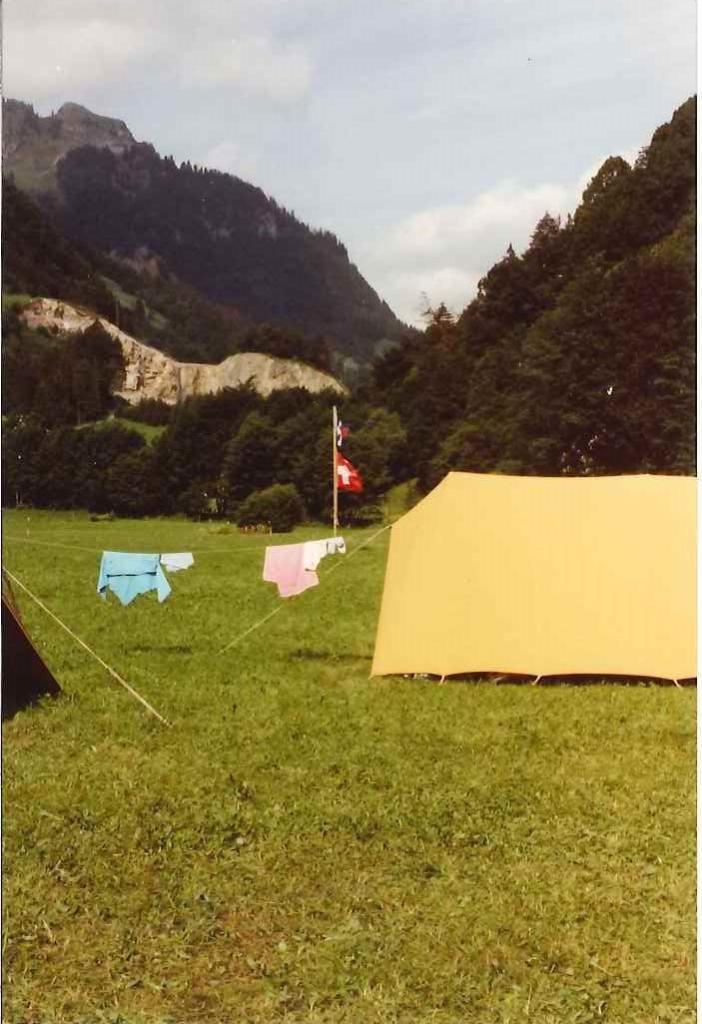What type of temporary shelter is visible in the image? There are tents in the image. What are the ropes used for in the image? The ropes are likely used to secure the tents or other items in the image. What type of clothing can be seen in the image? There are clothes in the image. What type of terrain is visible in the image? There is grass in the image, and the background includes trees and hills. What is the condition of the sky in the image? The sky is visible in the background of the image, and it appears cloudy. What is the purpose of the pole in the image? The pole is likely used to support the tents or other items in the image. What are the flags used for in the image? The flags may be used for identification or decoration purposes in the image. What type of room is visible in the image? There is no room present in the image; it features tents, ropes, clothes, grass, trees, hills, a pole, and flags. What type of apparel is being worn by the tent in the image? Tents do not wear apparel; they are temporary shelters made of fabric. 